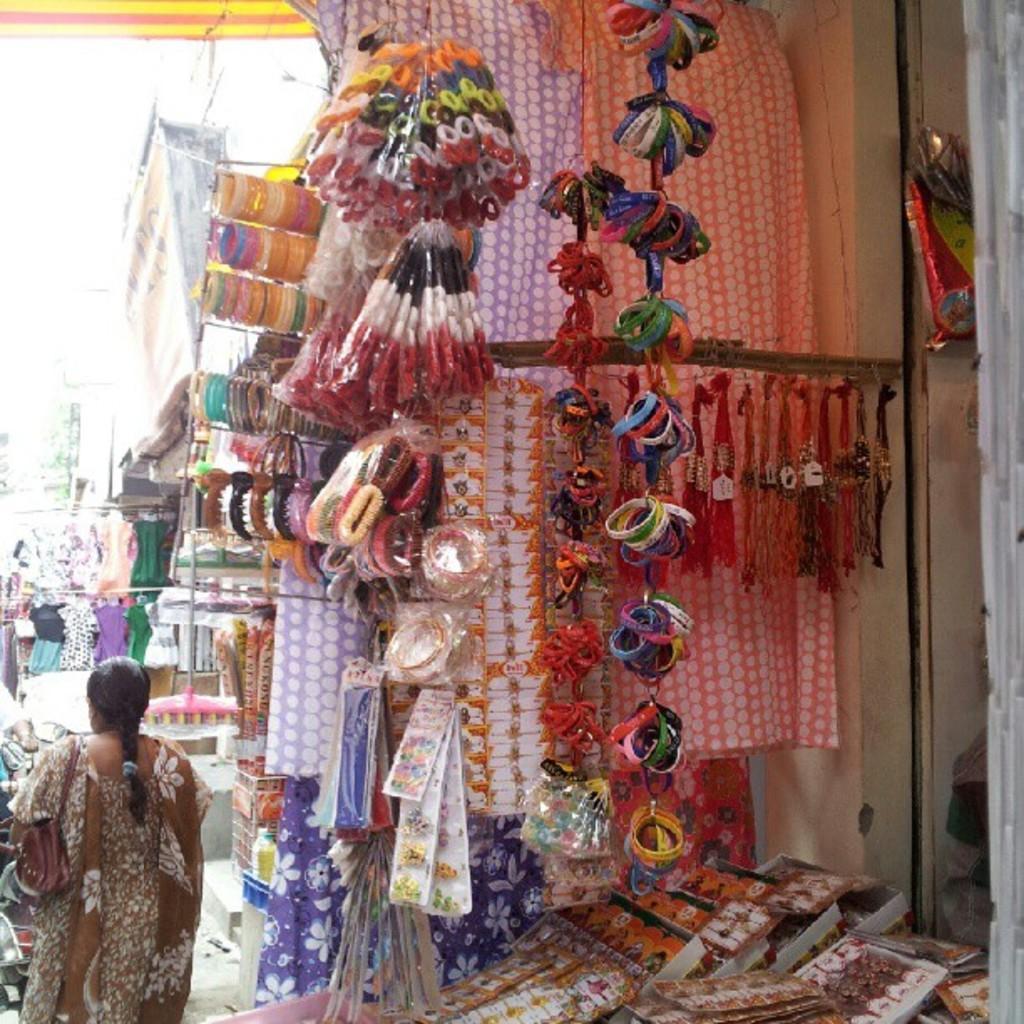Could you give a brief overview of what you see in this image? In this image there are few shops in which there are dresses, bangles and some other objects are hanging in front of the shops, there are few objects on a table in front of one of the shops, there are two persons and a bike on the road. 